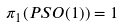Convert formula to latex. <formula><loc_0><loc_0><loc_500><loc_500>\pi _ { 1 } ( P S O ( 1 ) ) = 1</formula> 